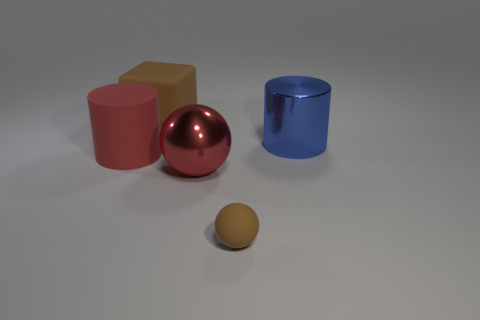Add 2 large cylinders. How many objects exist? 7 Subtract all cylinders. How many objects are left? 3 Subtract 1 red cylinders. How many objects are left? 4 Subtract all small gray cubes. Subtract all cubes. How many objects are left? 4 Add 1 large red balls. How many large red balls are left? 2 Add 3 large matte things. How many large matte things exist? 5 